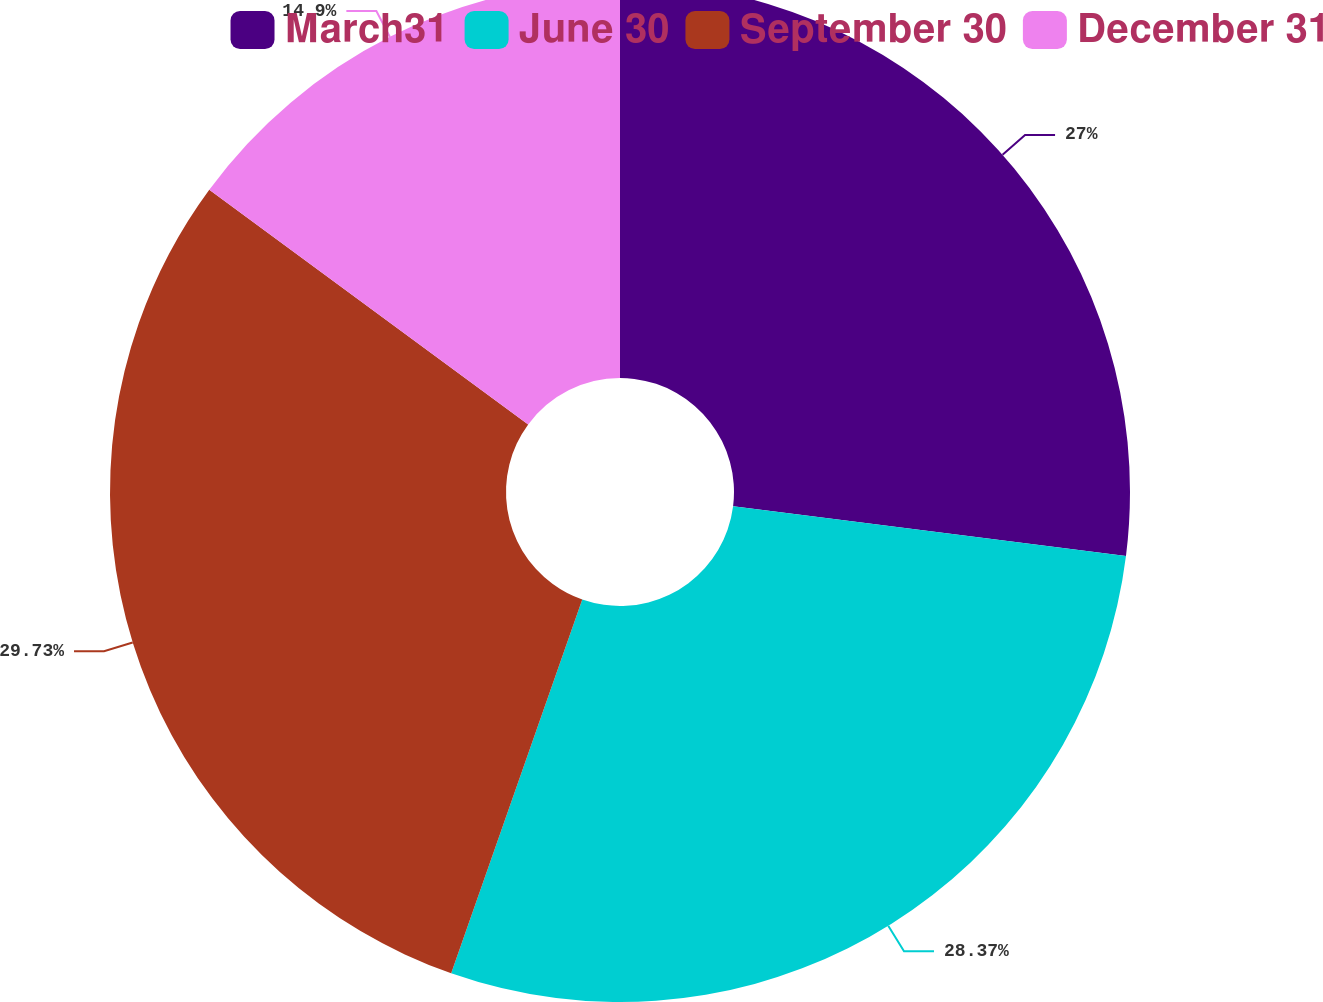Convert chart to OTSL. <chart><loc_0><loc_0><loc_500><loc_500><pie_chart><fcel>March31<fcel>June 30<fcel>September 30<fcel>December 31<nl><fcel>27.0%<fcel>28.37%<fcel>29.73%<fcel>14.9%<nl></chart> 